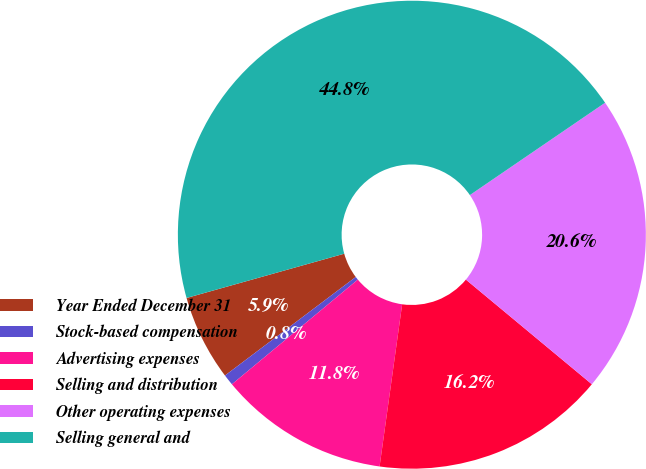Convert chart. <chart><loc_0><loc_0><loc_500><loc_500><pie_chart><fcel>Year Ended December 31<fcel>Stock-based compensation<fcel>Advertising expenses<fcel>Selling and distribution<fcel>Other operating expenses<fcel>Selling general and<nl><fcel>5.92%<fcel>0.76%<fcel>11.76%<fcel>16.17%<fcel>20.57%<fcel>44.82%<nl></chart> 